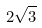Convert formula to latex. <formula><loc_0><loc_0><loc_500><loc_500>2 \sqrt { 3 }</formula> 